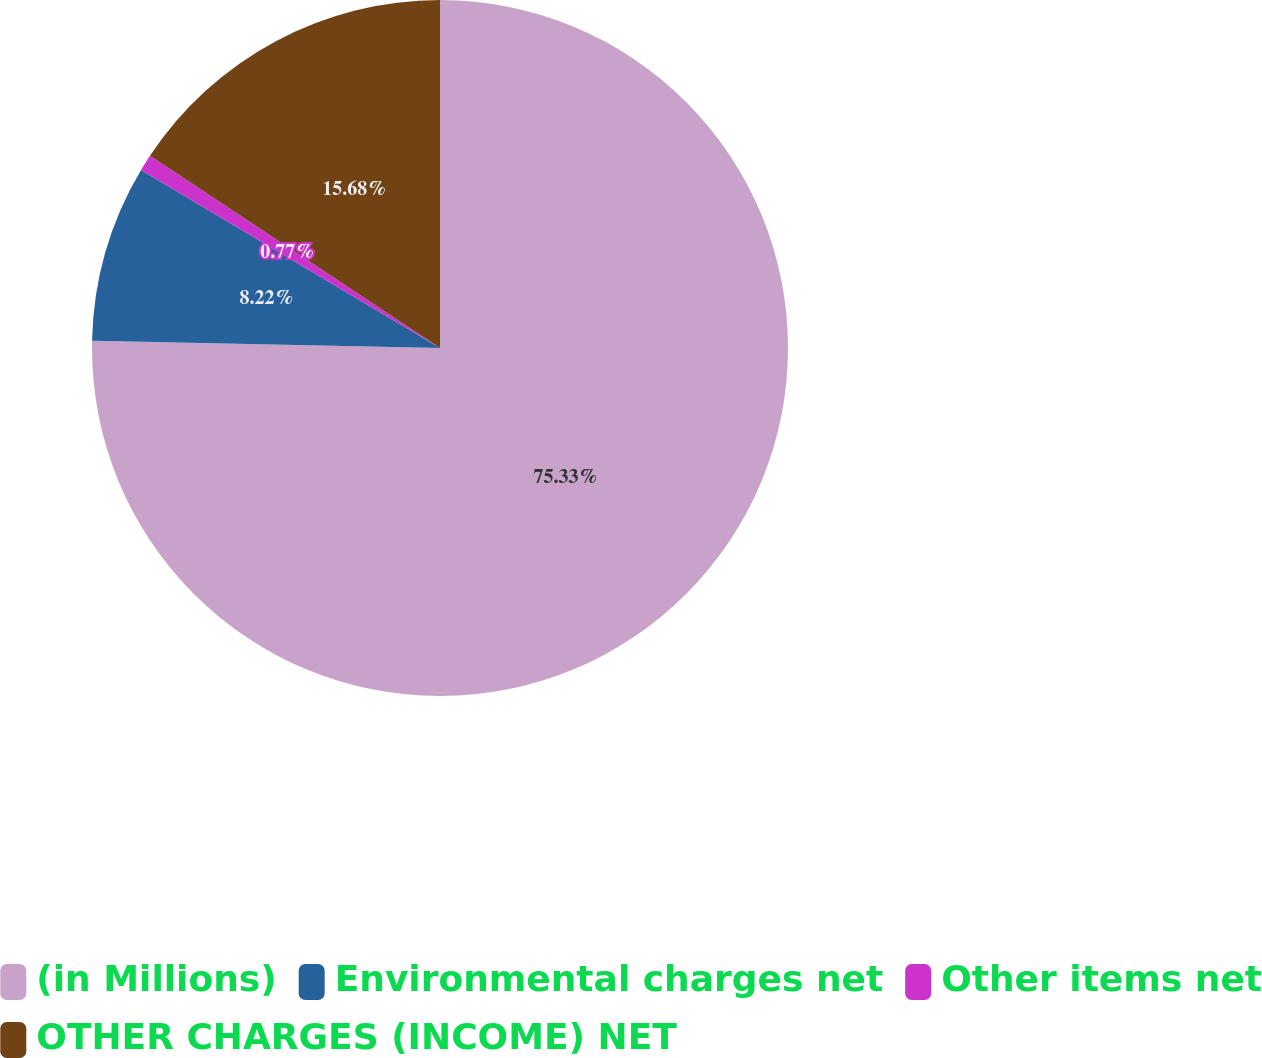Convert chart. <chart><loc_0><loc_0><loc_500><loc_500><pie_chart><fcel>(in Millions)<fcel>Environmental charges net<fcel>Other items net<fcel>OTHER CHARGES (INCOME) NET<nl><fcel>75.33%<fcel>8.22%<fcel>0.77%<fcel>15.68%<nl></chart> 